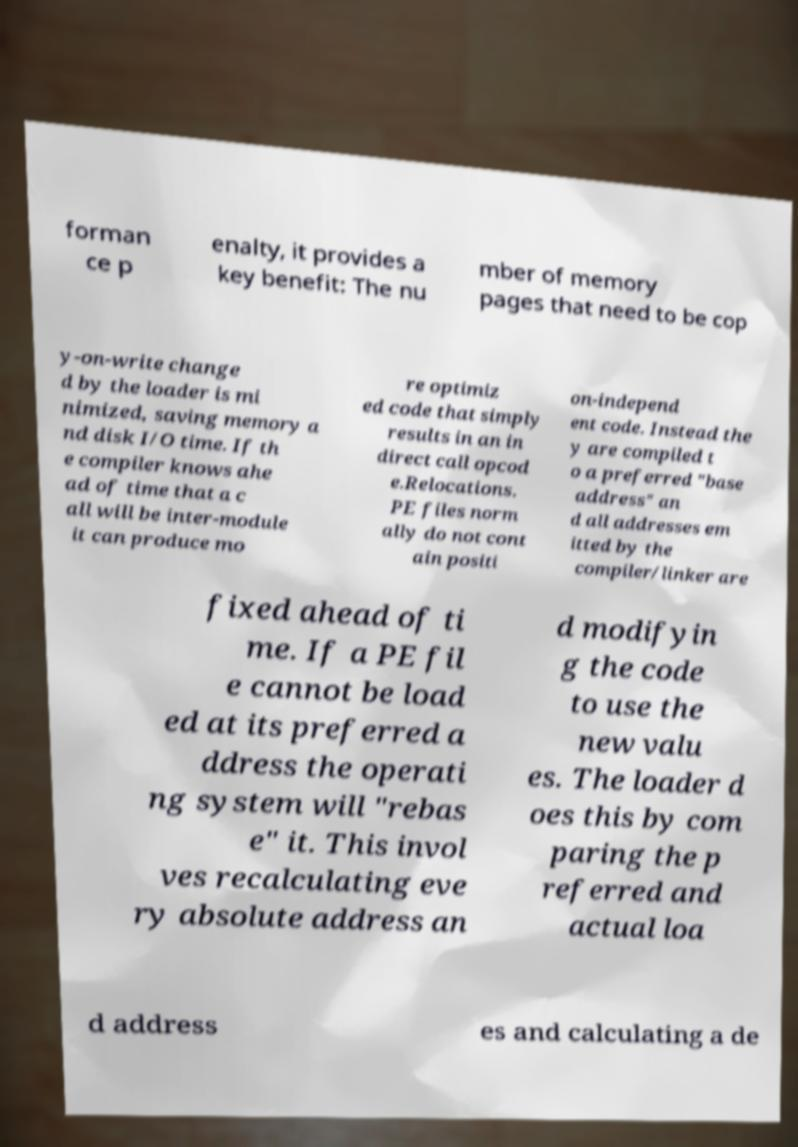Please identify and transcribe the text found in this image. forman ce p enalty, it provides a key benefit: The nu mber of memory pages that need to be cop y-on-write change d by the loader is mi nimized, saving memory a nd disk I/O time. If th e compiler knows ahe ad of time that a c all will be inter-module it can produce mo re optimiz ed code that simply results in an in direct call opcod e.Relocations. PE files norm ally do not cont ain positi on-independ ent code. Instead the y are compiled t o a preferred "base address" an d all addresses em itted by the compiler/linker are fixed ahead of ti me. If a PE fil e cannot be load ed at its preferred a ddress the operati ng system will "rebas e" it. This invol ves recalculating eve ry absolute address an d modifyin g the code to use the new valu es. The loader d oes this by com paring the p referred and actual loa d address es and calculating a de 